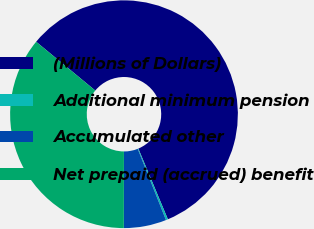Convert chart. <chart><loc_0><loc_0><loc_500><loc_500><pie_chart><fcel>(Millions of Dollars)<fcel>Additional minimum pension<fcel>Accumulated other<fcel>Net prepaid (accrued) benefit<nl><fcel>57.72%<fcel>0.29%<fcel>6.03%<fcel>35.96%<nl></chart> 